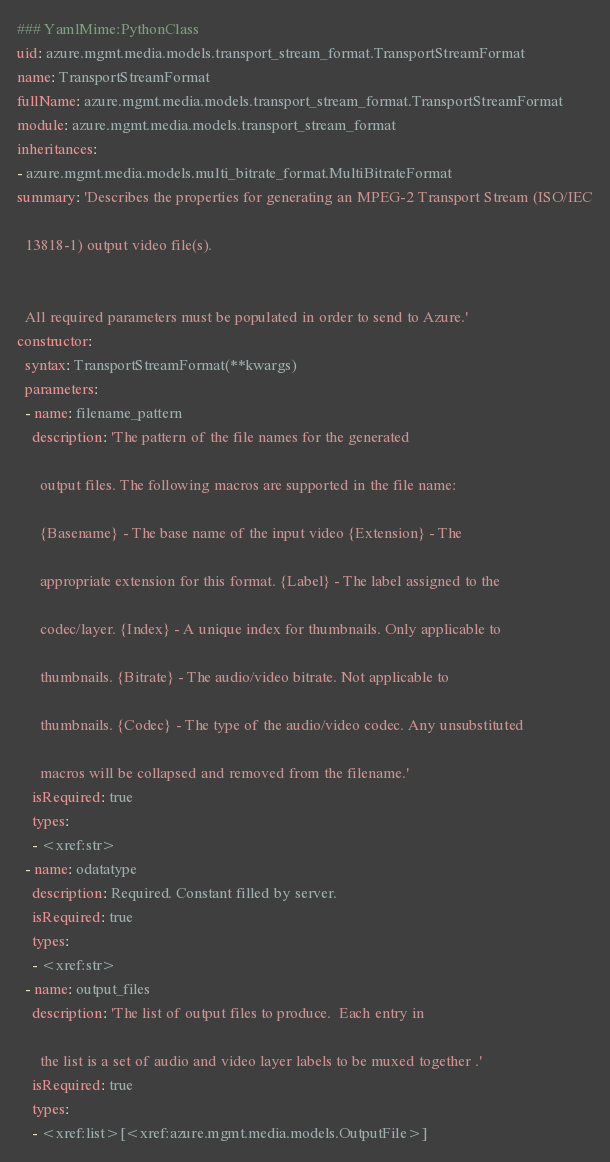Convert code to text. <code><loc_0><loc_0><loc_500><loc_500><_YAML_>### YamlMime:PythonClass
uid: azure.mgmt.media.models.transport_stream_format.TransportStreamFormat
name: TransportStreamFormat
fullName: azure.mgmt.media.models.transport_stream_format.TransportStreamFormat
module: azure.mgmt.media.models.transport_stream_format
inheritances:
- azure.mgmt.media.models.multi_bitrate_format.MultiBitrateFormat
summary: 'Describes the properties for generating an MPEG-2 Transport Stream (ISO/IEC

  13818-1) output video file(s).


  All required parameters must be populated in order to send to Azure.'
constructor:
  syntax: TransportStreamFormat(**kwargs)
  parameters:
  - name: filename_pattern
    description: 'The pattern of the file names for the generated

      output files. The following macros are supported in the file name:

      {Basename} - The base name of the input video {Extension} - The

      appropriate extension for this format. {Label} - The label assigned to the

      codec/layer. {Index} - A unique index for thumbnails. Only applicable to

      thumbnails. {Bitrate} - The audio/video bitrate. Not applicable to

      thumbnails. {Codec} - The type of the audio/video codec. Any unsubstituted

      macros will be collapsed and removed from the filename.'
    isRequired: true
    types:
    - <xref:str>
  - name: odatatype
    description: Required. Constant filled by server.
    isRequired: true
    types:
    - <xref:str>
  - name: output_files
    description: 'The list of output files to produce.  Each entry in

      the list is a set of audio and video layer labels to be muxed together .'
    isRequired: true
    types:
    - <xref:list>[<xref:azure.mgmt.media.models.OutputFile>]
</code> 